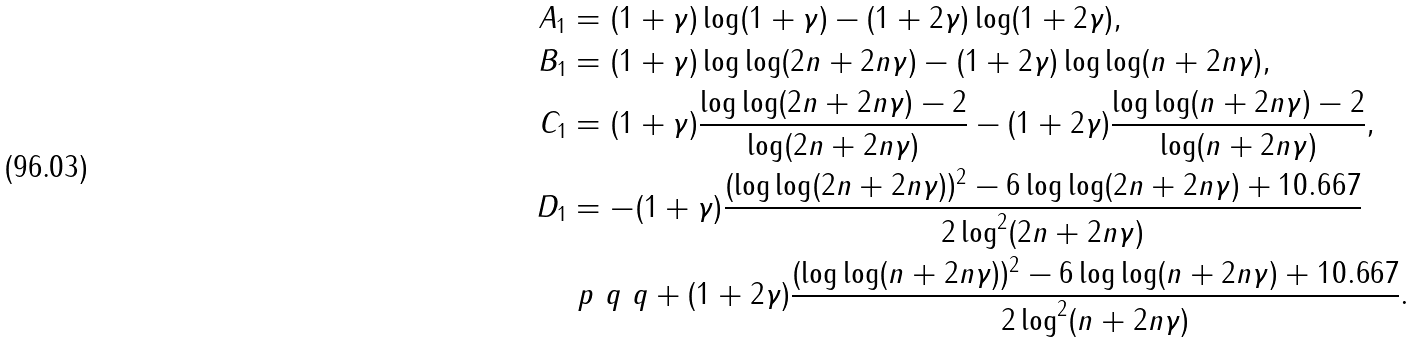Convert formula to latex. <formula><loc_0><loc_0><loc_500><loc_500>A _ { 1 } & = ( 1 + \gamma ) \log ( 1 + \gamma ) - ( 1 + 2 \gamma ) \log ( 1 + 2 \gamma ) , \\ B _ { 1 } & = ( 1 + \gamma ) \log \log ( 2 n + 2 n \gamma ) - ( 1 + 2 \gamma ) \log \log ( n + 2 n \gamma ) , \\ C _ { 1 } & = ( 1 + \gamma ) \frac { \log \log ( 2 n + 2 n \gamma ) - 2 } { \log ( 2 n + 2 n \gamma ) } - ( 1 + 2 \gamma ) \frac { \log \log ( n + 2 n \gamma ) - 2 } { \log ( n + 2 n \gamma ) } , \\ D _ { 1 } & = - ( 1 + \gamma ) \frac { ( \log \log ( 2 n + 2 n \gamma ) ) ^ { 2 } - 6 \log \log ( 2 n + 2 n \gamma ) + 1 0 . 6 6 7 } { 2 \log ^ { 2 } ( 2 n + 2 n \gamma ) } \\ & \ p { \ q \ q } + ( 1 + 2 \gamma ) \frac { ( \log \log ( n + 2 n \gamma ) ) ^ { 2 } - 6 \log \log ( n + 2 n \gamma ) + 1 0 . 6 6 7 } { 2 \log ^ { 2 } ( n + 2 n \gamma ) } .</formula> 